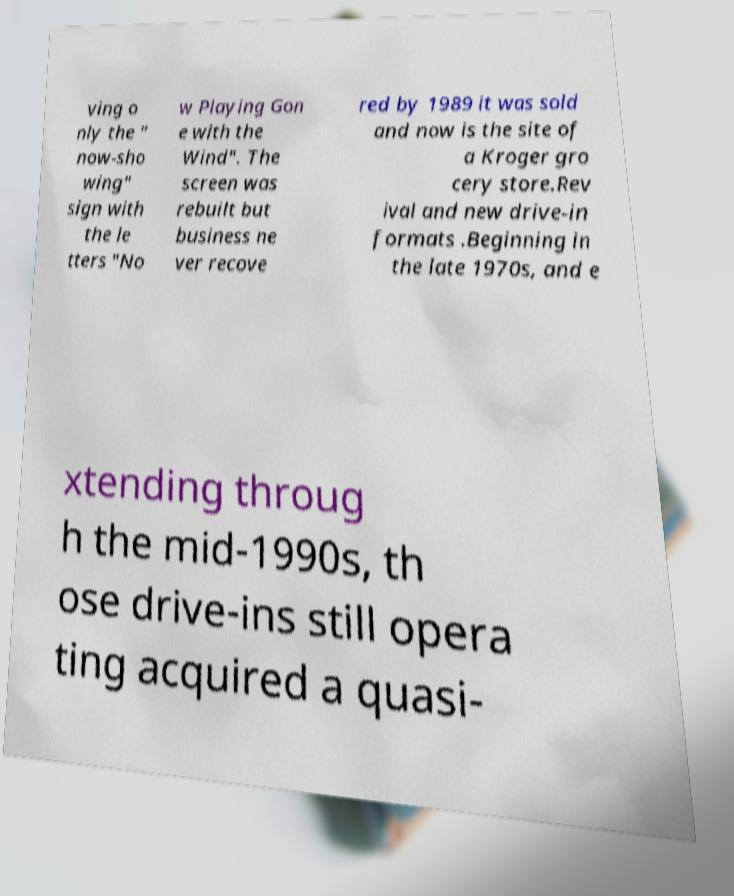Can you accurately transcribe the text from the provided image for me? ving o nly the " now-sho wing" sign with the le tters "No w Playing Gon e with the Wind". The screen was rebuilt but business ne ver recove red by 1989 it was sold and now is the site of a Kroger gro cery store.Rev ival and new drive-in formats .Beginning in the late 1970s, and e xtending throug h the mid-1990s, th ose drive-ins still opera ting acquired a quasi- 